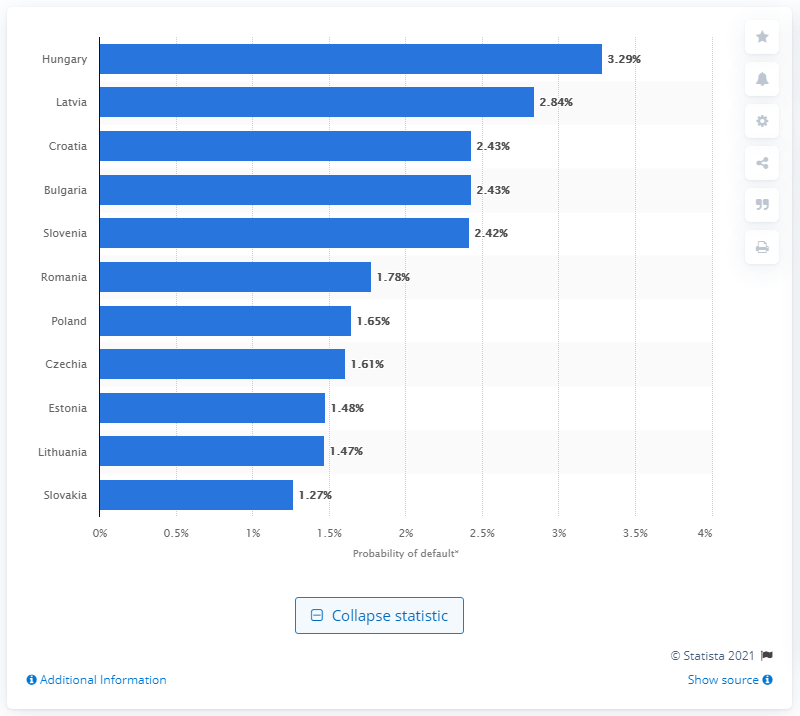List a handful of essential elements in this visual. In the first quarter of 2020, the probability of default on retail loans in Latvia was 2.84%. The probability of a retail loan defaulting in Hungary during the first quarter of 2020 was 3.29%. Latvia had the second highest probability of default on retail loans in Central and Eastern Europe, according to the data. 